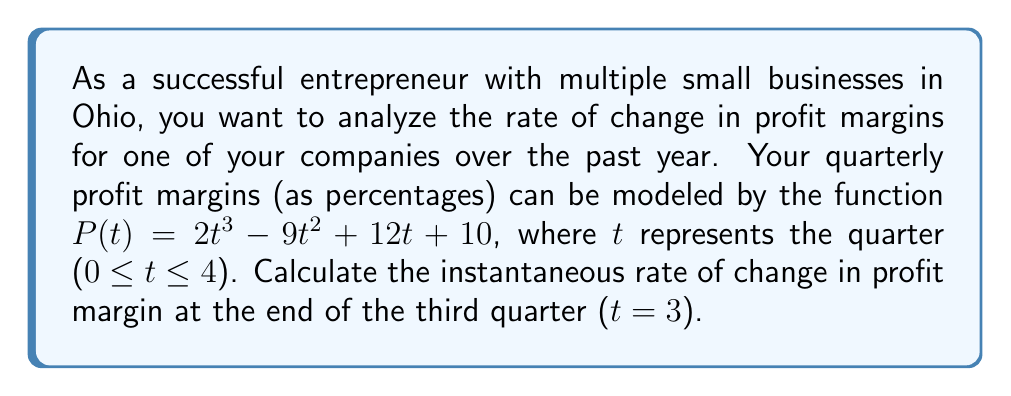Show me your answer to this math problem. To find the instantaneous rate of change in profit margin at t = 3, we need to calculate the derivative of the profit margin function P(t) and evaluate it at t = 3.

1. Given profit margin function: $P(t) = 2t^3 - 9t^2 + 12t + 10$

2. Calculate the derivative P'(t):
   $$\begin{align}
   P'(t) &= \frac{d}{dt}(2t^3 - 9t^2 + 12t + 10) \\
   &= 6t^2 - 18t + 12
   \end{align}$$

3. Evaluate P'(t) at t = 3:
   $$\begin{align}
   P'(3) &= 6(3)^2 - 18(3) + 12 \\
   &= 6(9) - 54 + 12 \\
   &= 54 - 54 + 12 \\
   &= 12
   \end{align}$$

The instantaneous rate of change at t = 3 is 12 percentage points per quarter.
Answer: 12 percentage points per quarter 